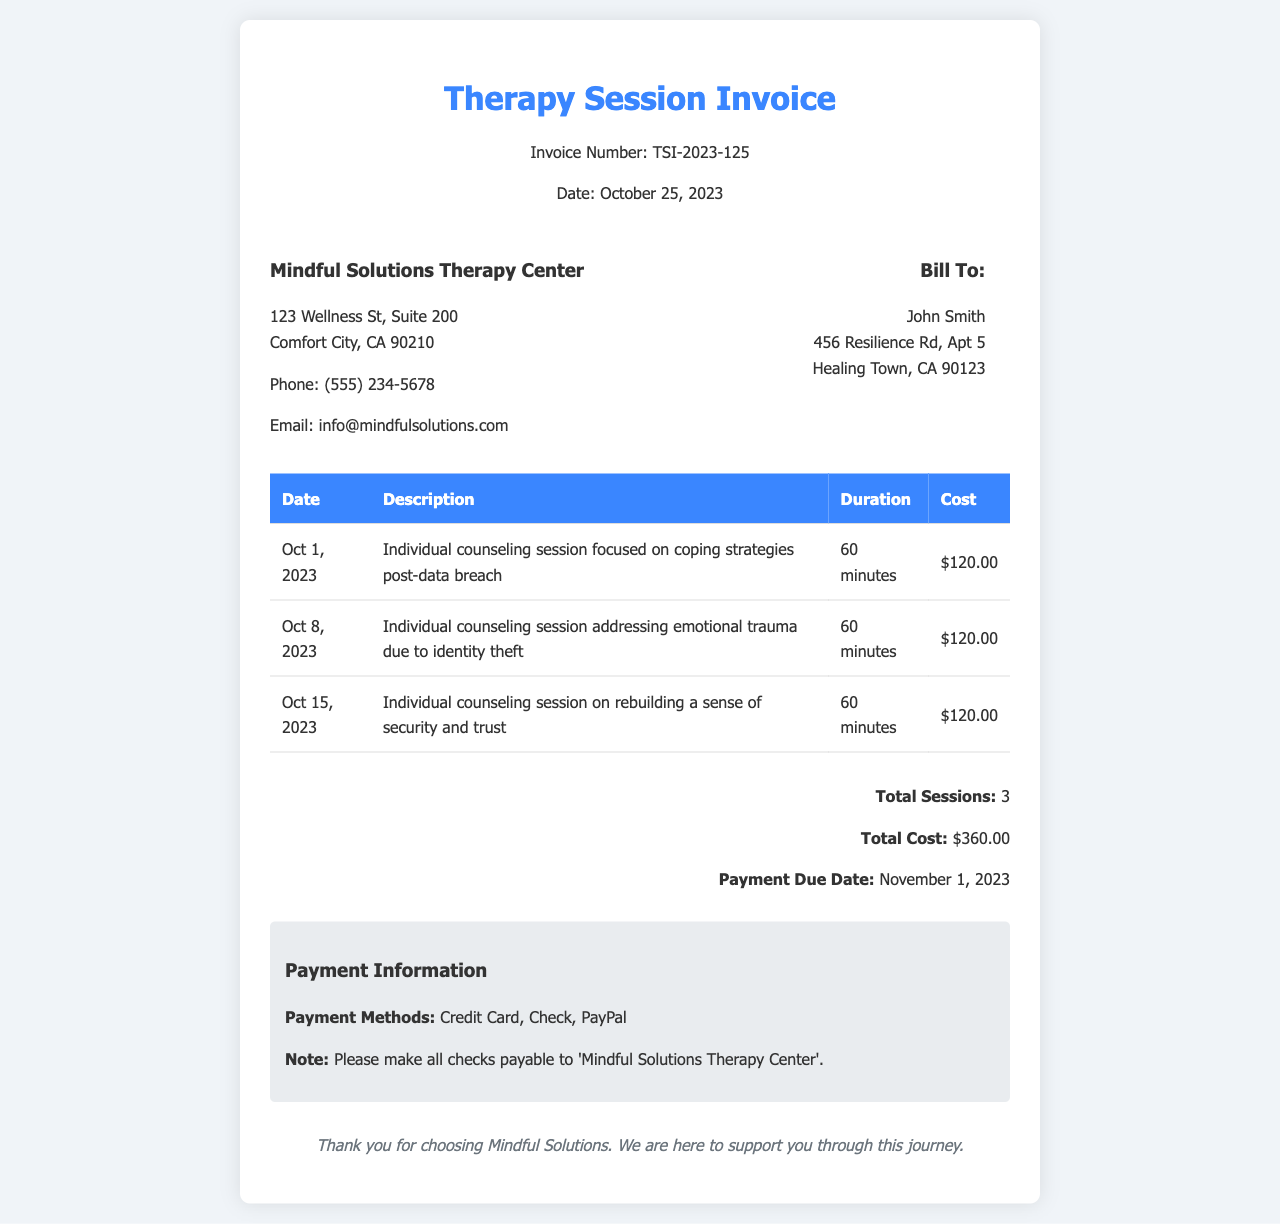What is the invoice number? The invoice number is a unique identifier assigned to this document, which is found in the header section.
Answer: TSI-2023-125 What is the total cost of the sessions? The total cost is calculated by summing the cost of all individual sessions listed in the document.
Answer: $360.00 Who is the client billed in the invoice? The client's name is specified under the "Bill To" section in the document.
Answer: John Smith What is the date of the first therapy session? The date of the first therapy session can be found in the session table provided in the document.
Answer: Oct 1, 2023 What payment methods are accepted? The payment methods are provided in the payment information section of the document.
Answer: Credit Card, Check, PayPal How many sessions are listed in the invoice? The number of sessions can be counted from the table in the document.
Answer: 3 What is the payment due date? The payment due date is specified in the summary section of the invoice.
Answer: November 1, 2023 What is the duration of each counseling session? The duration of sessions is consistent and can be found in the table's description section.
Answer: 60 minutes What is the focus of the second counseling session? The focus of the session is detailed in the description for that specific date in the document.
Answer: Emotional trauma due to identity theft 